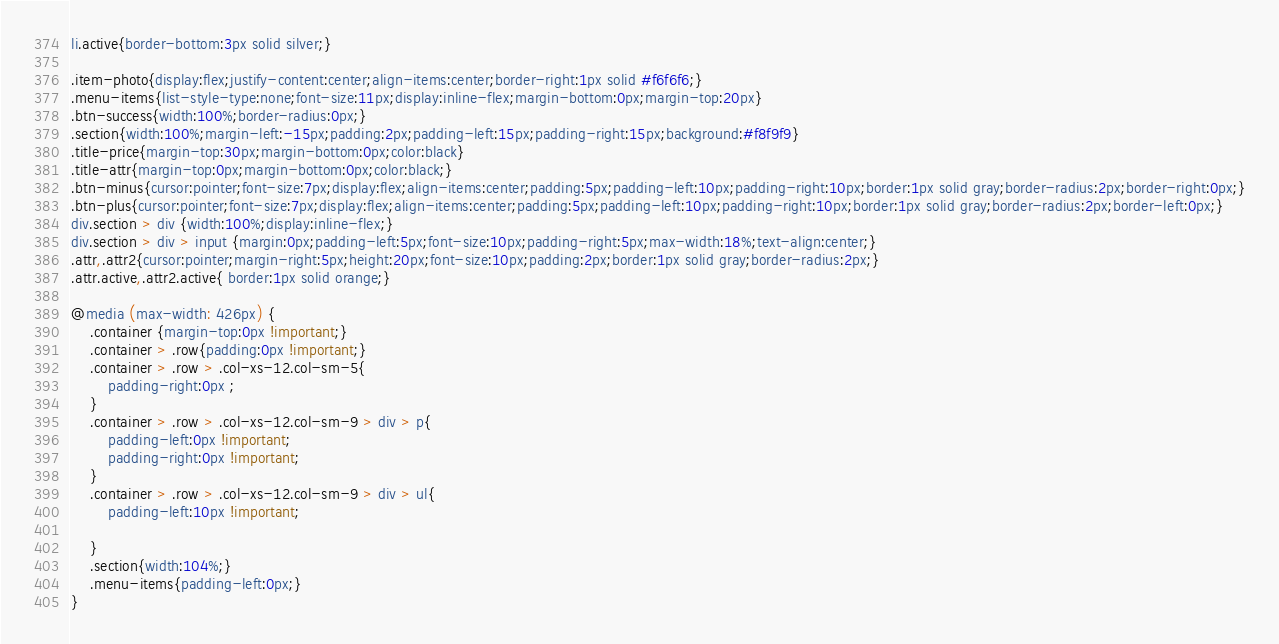<code> <loc_0><loc_0><loc_500><loc_500><_CSS_>li.active{border-bottom:3px solid silver;}

.item-photo{display:flex;justify-content:center;align-items:center;border-right:1px solid #f6f6f6;}
.menu-items{list-style-type:none;font-size:11px;display:inline-flex;margin-bottom:0px;margin-top:20px}
.btn-success{width:100%;border-radius:0px;}
.section{width:100%;margin-left:-15px;padding:2px;padding-left:15px;padding-right:15px;background:#f8f9f9}
.title-price{margin-top:30px;margin-bottom:0px;color:black}
.title-attr{margin-top:0px;margin-bottom:0px;color:black;}
.btn-minus{cursor:pointer;font-size:7px;display:flex;align-items:center;padding:5px;padding-left:10px;padding-right:10px;border:1px solid gray;border-radius:2px;border-right:0px;}
.btn-plus{cursor:pointer;font-size:7px;display:flex;align-items:center;padding:5px;padding-left:10px;padding-right:10px;border:1px solid gray;border-radius:2px;border-left:0px;}
div.section > div {width:100%;display:inline-flex;}
div.section > div > input {margin:0px;padding-left:5px;font-size:10px;padding-right:5px;max-width:18%;text-align:center;}
.attr,.attr2{cursor:pointer;margin-right:5px;height:20px;font-size:10px;padding:2px;border:1px solid gray;border-radius:2px;}
.attr.active,.attr2.active{ border:1px solid orange;}

@media (max-width: 426px) {
    .container {margin-top:0px !important;}
    .container > .row{padding:0px !important;}
    .container > .row > .col-xs-12.col-sm-5{
        padding-right:0px ;
    }
    .container > .row > .col-xs-12.col-sm-9 > div > p{
        padding-left:0px !important;
        padding-right:0px !important;
    }
    .container > .row > .col-xs-12.col-sm-9 > div > ul{
        padding-left:10px !important;

    }
    .section{width:104%;}
    .menu-items{padding-left:0px;}
}

</code> 